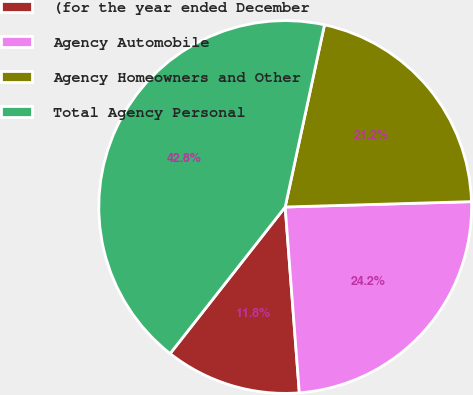Convert chart. <chart><loc_0><loc_0><loc_500><loc_500><pie_chart><fcel>(for the year ended December<fcel>Agency Automobile<fcel>Agency Homeowners and Other<fcel>Total Agency Personal<nl><fcel>11.8%<fcel>24.25%<fcel>21.16%<fcel>42.79%<nl></chart> 